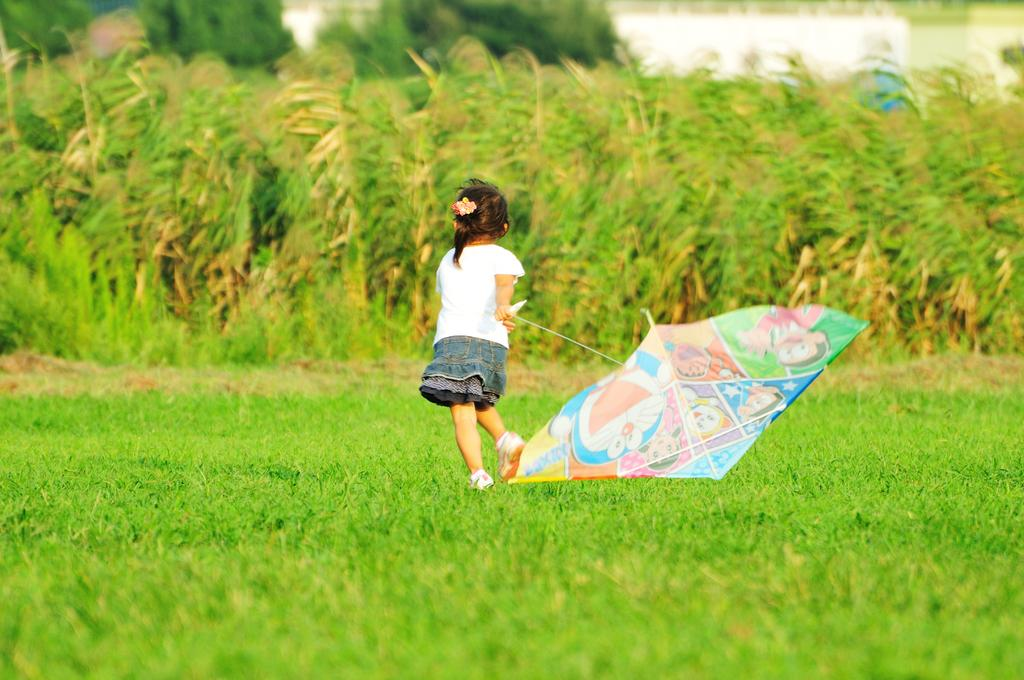What is the main subject of the image? The main subject of the image is a kid. What is the kid wearing in the image? The kid is wearing clothes in the image. What activity is the kid engaged in? The kid is flying a kite in the image. What type of terrain is visible in the image? There is grass on the ground in the image. What else can be seen in the image besides the kid and the grass? There are plants in the middle of the image. What type of bait is the kid using to catch fish in the image? There is no indication in the image that the kid is trying to catch fish, nor is there any bait present. What color is the lip of the kite in the image? The provided facts do not mention the color of the kite's lip, nor is it visible in the image. 